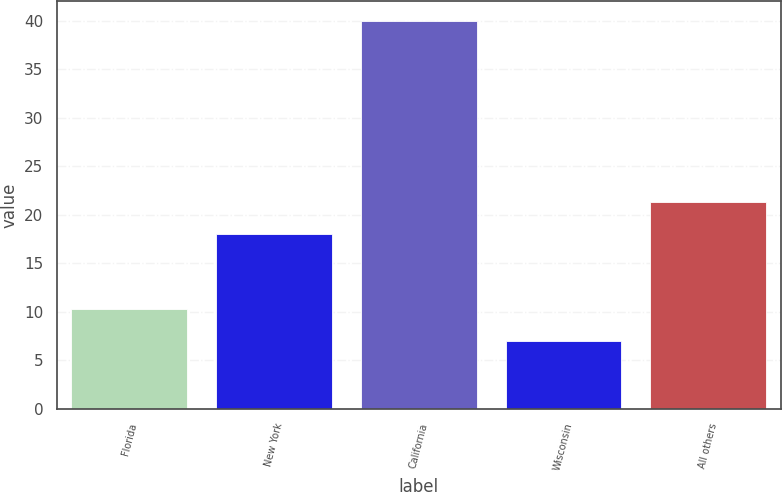Convert chart to OTSL. <chart><loc_0><loc_0><loc_500><loc_500><bar_chart><fcel>Florida<fcel>New York<fcel>California<fcel>Wisconsin<fcel>All others<nl><fcel>10.3<fcel>18<fcel>40<fcel>7<fcel>21.3<nl></chart> 